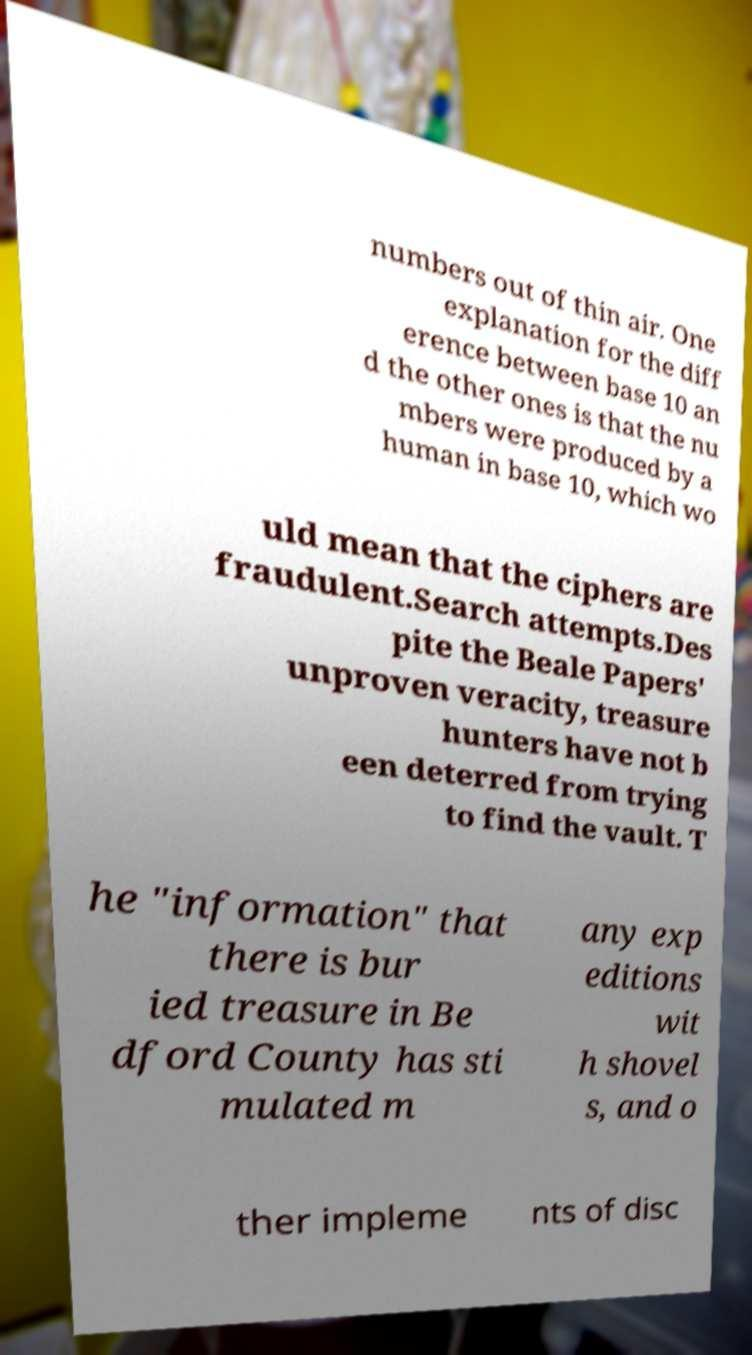Could you extract and type out the text from this image? numbers out of thin air. One explanation for the diff erence between base 10 an d the other ones is that the nu mbers were produced by a human in base 10, which wo uld mean that the ciphers are fraudulent.Search attempts.Des pite the Beale Papers' unproven veracity, treasure hunters have not b een deterred from trying to find the vault. T he "information" that there is bur ied treasure in Be dford County has sti mulated m any exp editions wit h shovel s, and o ther impleme nts of disc 